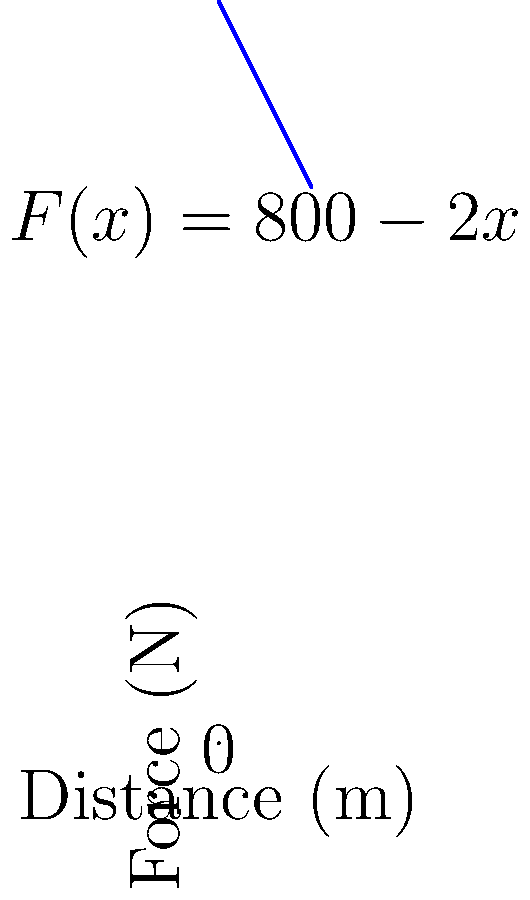As a former state champion sprinter, you're analyzing your performance in a 100-meter dash. The force you exert while sprinting decreases linearly from 800 N at the start to 600 N at the finish. Calculate the total work done during the sprint using integration. Let's approach this step-by-step:

1) First, we need to express the force as a function of distance. We know:
   - At $x = 0$ m, $F = 800$ N
   - At $x = 100$ m, $F = 600$ N

2) We can represent this linear relationship as $F(x) = 800 - 2x$

3) Work is calculated by integrating force over distance:

   $W = \int_{0}^{100} F(x) dx$

4) Substituting our force function:

   $W = \int_{0}^{100} (800 - 2x) dx$

5) Integrate:
   $W = [800x - x^2]_{0}^{100}$

6) Evaluate the integral:
   $W = (80000 - 10000) - (0 - 0) = 70000$

7) The units of work are Newton-meters or Joules.

Therefore, the total work done is 70,000 J.
Answer: 70,000 J 